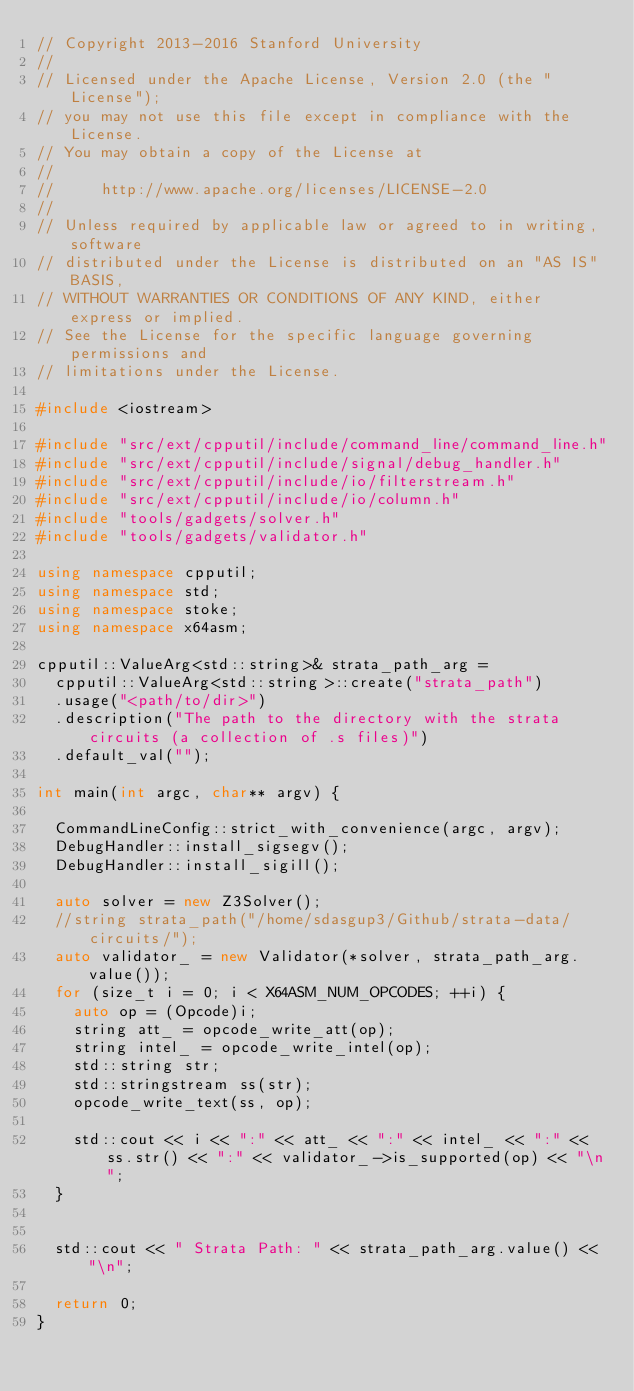<code> <loc_0><loc_0><loc_500><loc_500><_C++_>// Copyright 2013-2016 Stanford University
//
// Licensed under the Apache License, Version 2.0 (the "License");
// you may not use this file except in compliance with the License.
// You may obtain a copy of the License at
//
//     http://www.apache.org/licenses/LICENSE-2.0
//
// Unless required by applicable law or agreed to in writing, software
// distributed under the License is distributed on an "AS IS" BASIS,
// WITHOUT WARRANTIES OR CONDITIONS OF ANY KIND, either express or implied.
// See the License for the specific language governing permissions and
// limitations under the License.

#include <iostream>

#include "src/ext/cpputil/include/command_line/command_line.h"
#include "src/ext/cpputil/include/signal/debug_handler.h"
#include "src/ext/cpputil/include/io/filterstream.h"
#include "src/ext/cpputil/include/io/column.h"
#include "tools/gadgets/solver.h"
#include "tools/gadgets/validator.h"

using namespace cpputil;
using namespace std;
using namespace stoke;
using namespace x64asm;

cpputil::ValueArg<std::string>& strata_path_arg =
  cpputil::ValueArg<std::string>::create("strata_path")
  .usage("<path/to/dir>")
  .description("The path to the directory with the strata circuits (a collection of .s files)")
  .default_val("");

int main(int argc, char** argv) {

  CommandLineConfig::strict_with_convenience(argc, argv);
  DebugHandler::install_sigsegv();
  DebugHandler::install_sigill();

  auto solver = new Z3Solver();
  //string strata_path("/home/sdasgup3/Github/strata-data/circuits/");
  auto validator_ = new Validator(*solver, strata_path_arg.value());
  for (size_t i = 0; i < X64ASM_NUM_OPCODES; ++i) {
    auto op = (Opcode)i;
    string att_ = opcode_write_att(op);
    string intel_ = opcode_write_intel(op);
    std::string str;
    std::stringstream ss(str);
    opcode_write_text(ss, op);

    std::cout << i << ":" << att_ << ":" << intel_ << ":" << ss.str() << ":" << validator_->is_supported(op) << "\n";
  }


  std::cout << " Strata Path: " << strata_path_arg.value() << "\n";

  return 0;
}
</code> 